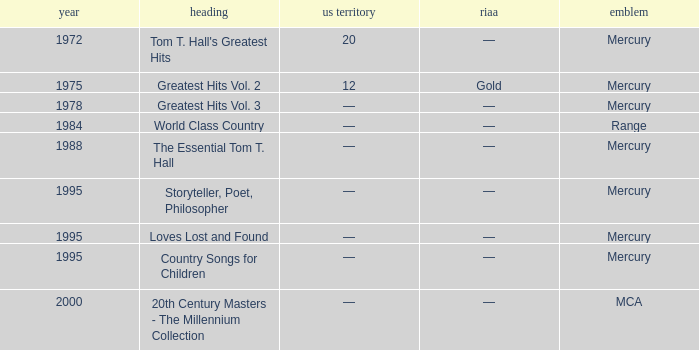What is the highest year for the title, "loves lost and found"? 1995.0. 